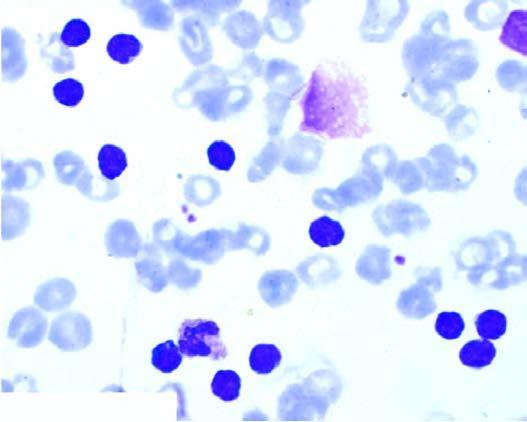what is large excess there of?
Answer the question using a single word or phrase. Of mature and small differentiated lymphocytes 